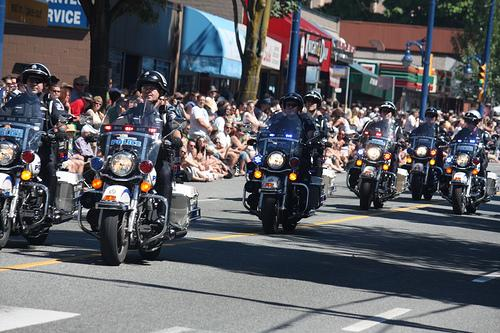Where do you go in this street if you want to buy candy?

Choices:
A) restaurant
B) convenience store
C) shoes store
D) bank convenience store 